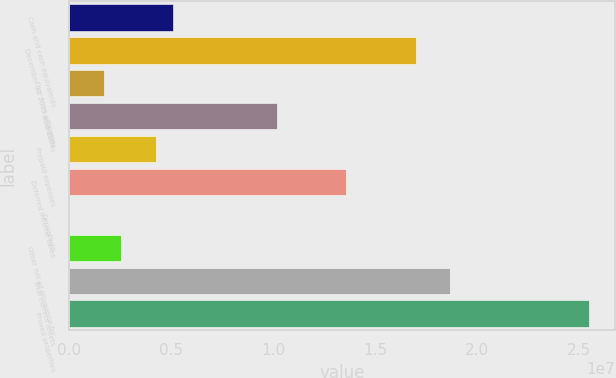Convert chart to OTSL. <chart><loc_0><loc_0><loc_500><loc_500><bar_chart><fcel>Cash and cash equivalents<fcel>December 31 2005 and 2004<fcel>Due from affiliates<fcel>Inventories<fcel>Prepaid expenses<fcel>Deferred income taxes<fcel>Derivatives<fcel>Other net of allowance for<fcel>Total current assets<fcel>Proved properties<nl><fcel>5.10005e+06<fcel>1.69973e+07<fcel>1.70085e+06<fcel>1.01989e+07<fcel>4.25025e+06<fcel>1.35981e+07<fcel>1246<fcel>2.55065e+06<fcel>1.86969e+07<fcel>2.54953e+07<nl></chart> 